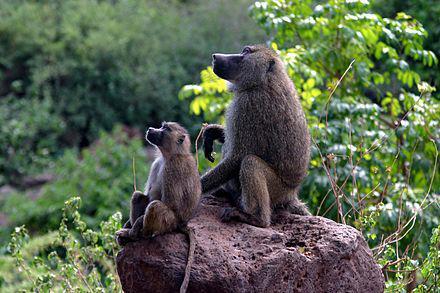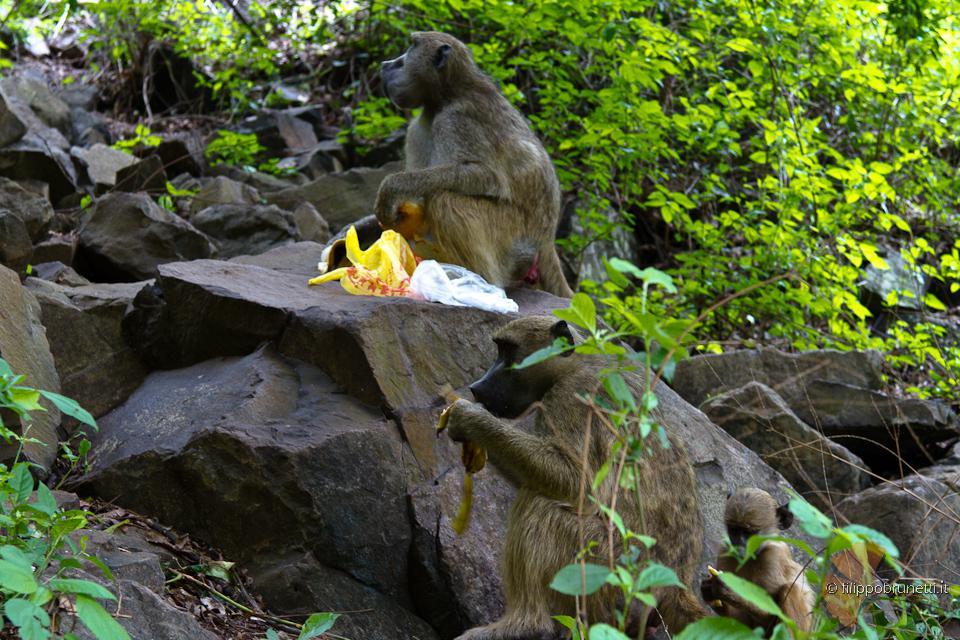The first image is the image on the left, the second image is the image on the right. Evaluate the accuracy of this statement regarding the images: "All baboons are pictured in the branches of trees, and baboons of different ages are included in the combined images.". Is it true? Answer yes or no. No. The first image is the image on the left, the second image is the image on the right. For the images displayed, is the sentence "The monkeys in each of the images are sitting in the trees." factually correct? Answer yes or no. No. 